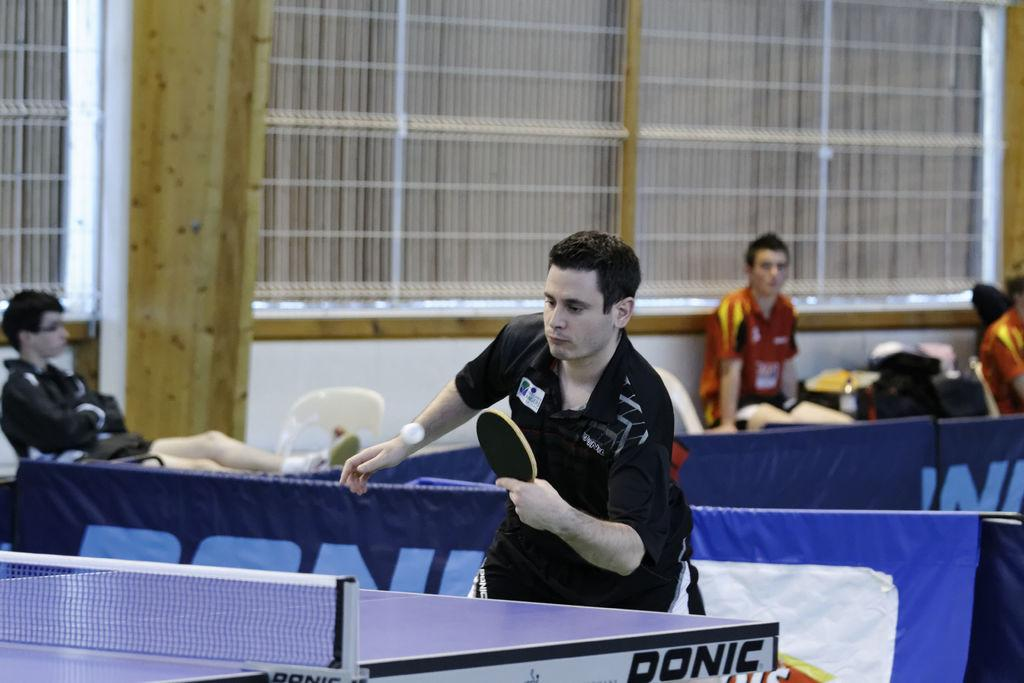How many people are in the image? There are people in the image, but the exact number is not specified. What is the man holding in the image? The man is holding a table tennis racket in the image. What object is present in the image that is commonly used in table tennis? There is a ball in the image. What type of furniture can be seen in the background of the image? There are chairs in the background of the image. What is the primary object in the image that is used for playing table tennis? There is a table tennis table in the image. Can you see a bridge in the image? No, there is no bridge present in the image. What type of horn is being used by the people in the image? There is no horn present in the image; the people are playing table tennis with a racket and a ball. 